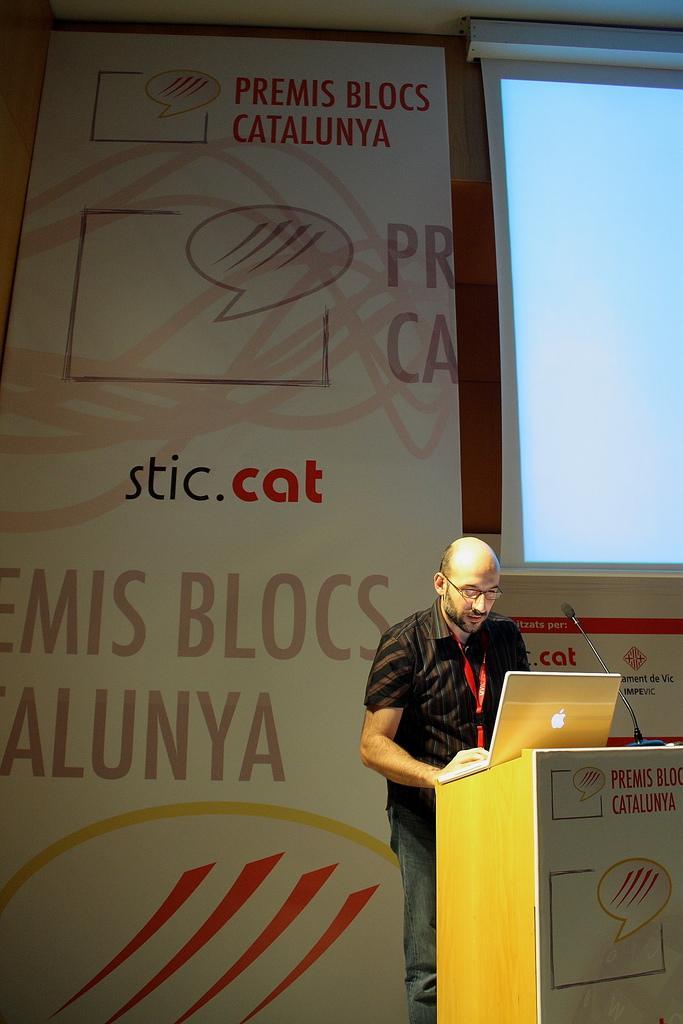In one or two sentences, can you explain what this image depicts? In this image we can see a person standing near a speaker stand containing a laptop and a mic with a stand. On the backside we can see the display screen and a wall with some text on it. 